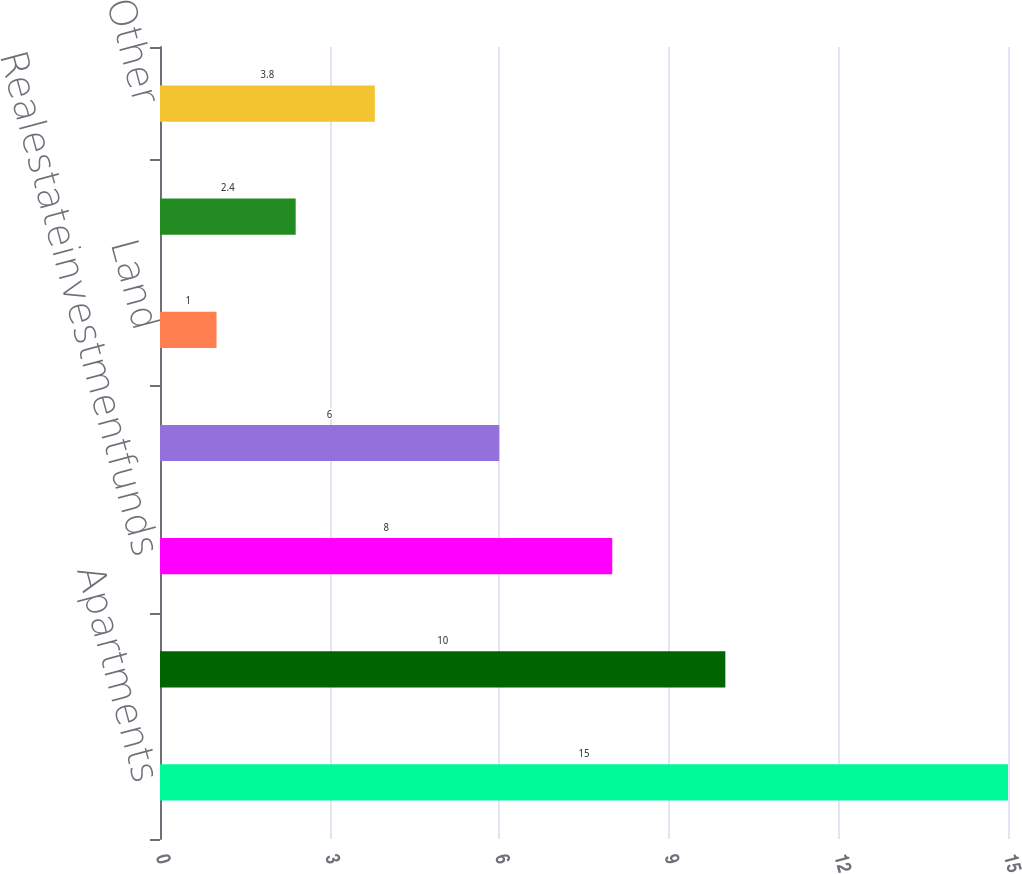Convert chart to OTSL. <chart><loc_0><loc_0><loc_500><loc_500><bar_chart><fcel>Apartments<fcel>Retail<fcel>Realestateinvestmentfunds<fcel>Industrial<fcel>Land<fcel>Agriculture<fcel>Other<nl><fcel>15<fcel>10<fcel>8<fcel>6<fcel>1<fcel>2.4<fcel>3.8<nl></chart> 